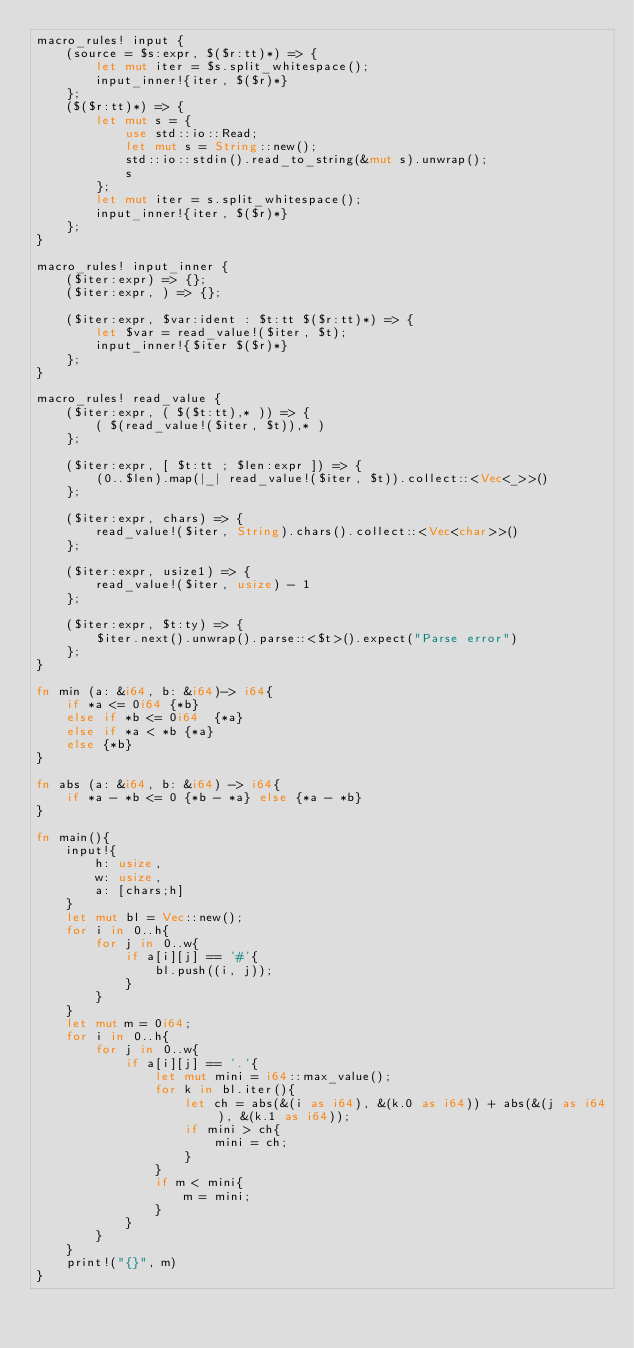<code> <loc_0><loc_0><loc_500><loc_500><_Rust_>macro_rules! input {
    (source = $s:expr, $($r:tt)*) => {
        let mut iter = $s.split_whitespace();
        input_inner!{iter, $($r)*}
    };
    ($($r:tt)*) => {
        let mut s = {
            use std::io::Read;
            let mut s = String::new();
            std::io::stdin().read_to_string(&mut s).unwrap();
            s
        };
        let mut iter = s.split_whitespace();
        input_inner!{iter, $($r)*}
    };
}

macro_rules! input_inner {
    ($iter:expr) => {};
    ($iter:expr, ) => {};

    ($iter:expr, $var:ident : $t:tt $($r:tt)*) => {
        let $var = read_value!($iter, $t);
        input_inner!{$iter $($r)*}
    };
}

macro_rules! read_value {
    ($iter:expr, ( $($t:tt),* )) => {
        ( $(read_value!($iter, $t)),* )
    };

    ($iter:expr, [ $t:tt ; $len:expr ]) => {
        (0..$len).map(|_| read_value!($iter, $t)).collect::<Vec<_>>()
    };

    ($iter:expr, chars) => {
        read_value!($iter, String).chars().collect::<Vec<char>>()
    };

    ($iter:expr, usize1) => {
        read_value!($iter, usize) - 1
    };

    ($iter:expr, $t:ty) => {
        $iter.next().unwrap().parse::<$t>().expect("Parse error")
    };
}

fn min (a: &i64, b: &i64)-> i64{
    if *a <= 0i64 {*b}
    else if *b <= 0i64  {*a}
    else if *a < *b {*a}
    else {*b}
}

fn abs (a: &i64, b: &i64) -> i64{
    if *a - *b <= 0 {*b - *a} else {*a - *b}
}

fn main(){
    input!{
        h: usize,
        w: usize,
        a: [chars;h]
    }
    let mut bl = Vec::new();
    for i in 0..h{
        for j in 0..w{
            if a[i][j] == '#'{
                bl.push((i, j));
            }
        }
    }
    let mut m = 0i64;
    for i in 0..h{
        for j in 0..w{
            if a[i][j] == '.'{
                let mut mini = i64::max_value();
                for k in bl.iter(){
                    let ch = abs(&(i as i64), &(k.0 as i64)) + abs(&(j as i64), &(k.1 as i64));
                    if mini > ch{
                        mini = ch;
                    }
                }
                if m < mini{
                    m = mini;
                }
            }
        }
    }
    print!("{}", m)
}
</code> 